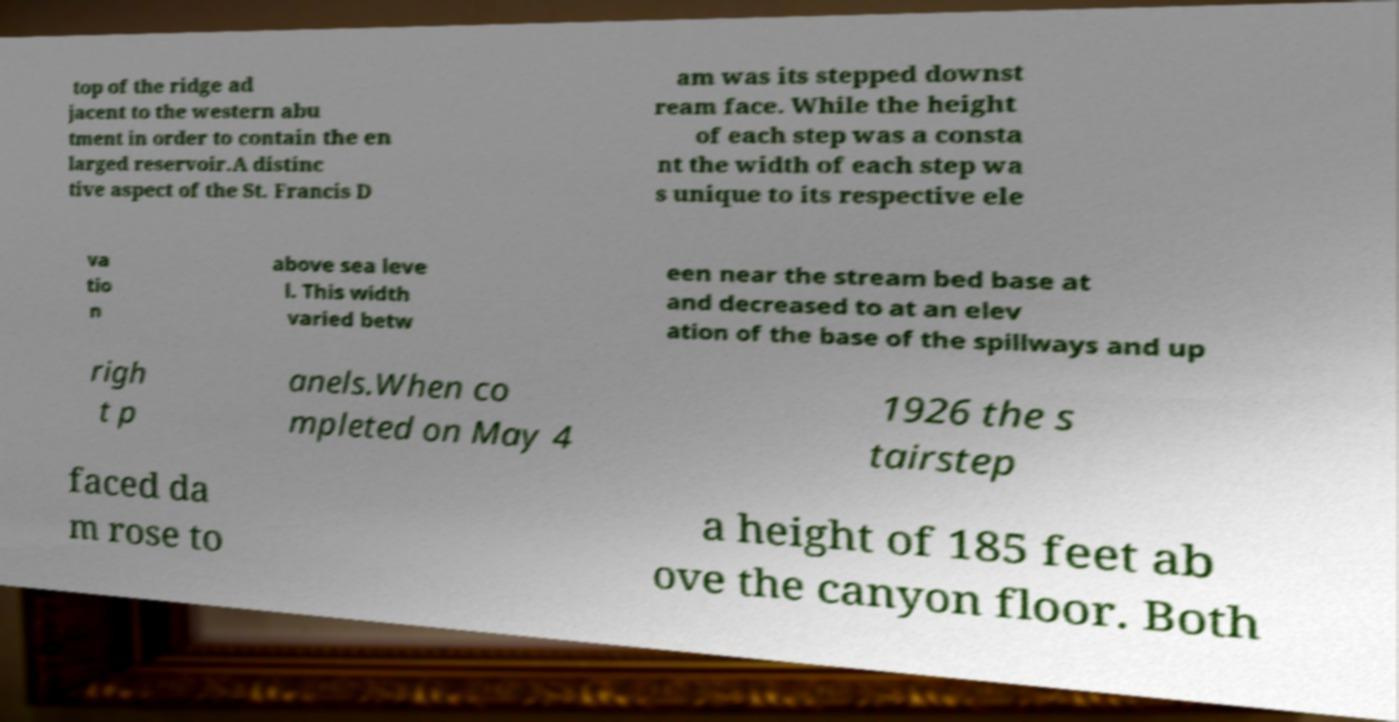Could you extract and type out the text from this image? top of the ridge ad jacent to the western abu tment in order to contain the en larged reservoir.A distinc tive aspect of the St. Francis D am was its stepped downst ream face. While the height of each step was a consta nt the width of each step wa s unique to its respective ele va tio n above sea leve l. This width varied betw een near the stream bed base at and decreased to at an elev ation of the base of the spillways and up righ t p anels.When co mpleted on May 4 1926 the s tairstep faced da m rose to a height of 185 feet ab ove the canyon floor. Both 